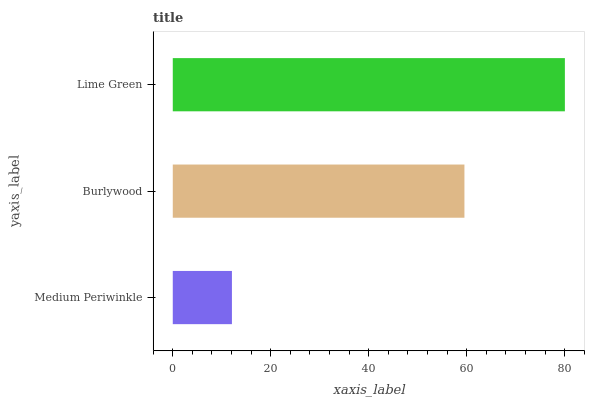Is Medium Periwinkle the minimum?
Answer yes or no. Yes. Is Lime Green the maximum?
Answer yes or no. Yes. Is Burlywood the minimum?
Answer yes or no. No. Is Burlywood the maximum?
Answer yes or no. No. Is Burlywood greater than Medium Periwinkle?
Answer yes or no. Yes. Is Medium Periwinkle less than Burlywood?
Answer yes or no. Yes. Is Medium Periwinkle greater than Burlywood?
Answer yes or no. No. Is Burlywood less than Medium Periwinkle?
Answer yes or no. No. Is Burlywood the high median?
Answer yes or no. Yes. Is Burlywood the low median?
Answer yes or no. Yes. Is Lime Green the high median?
Answer yes or no. No. Is Medium Periwinkle the low median?
Answer yes or no. No. 